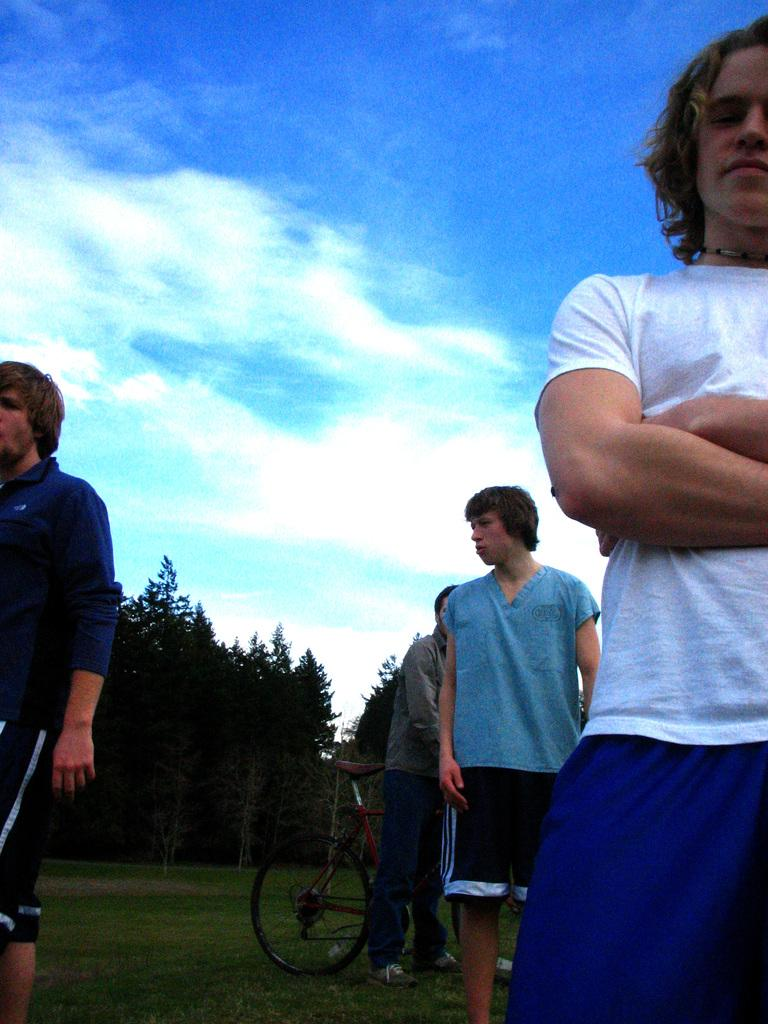What can be seen in the background of the image? There is a sky in the image. What type of vegetation is present in the image? There is a tree in the image. Who or what is present in the image? There are people in the image. What mode of transportation can be seen in the image? There is a bicycle in the image. What type of pickle is being used as a hat by the person in the image? There is no pickle present in the image, nor is anyone wearing a pickle as a hat. 